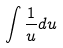Convert formula to latex. <formula><loc_0><loc_0><loc_500><loc_500>\int \frac { 1 } { u } d u</formula> 